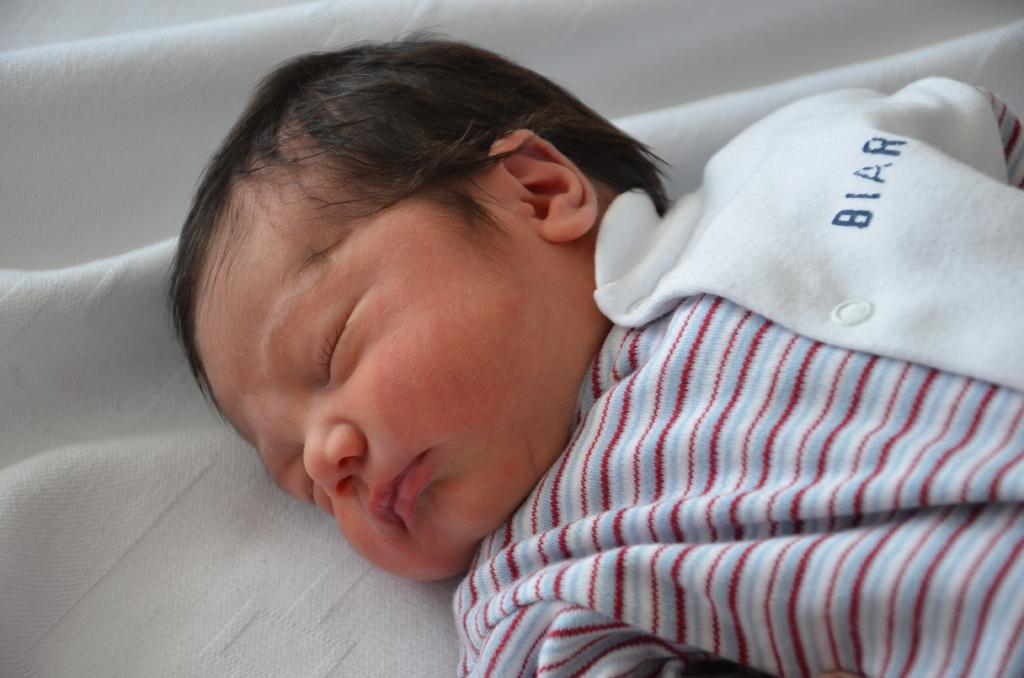What is the main subject of the image? The main subject of the image is a baby. What is the baby wearing in the image? The baby is wearing a dress in the image. What is the baby laying on in the image? The baby is laying on a cloth in the image. What request does the baby make in the image? There is no indication in the image that the baby is making a request, as it is a still image and does not depict any actions or expressions that suggest a request. 